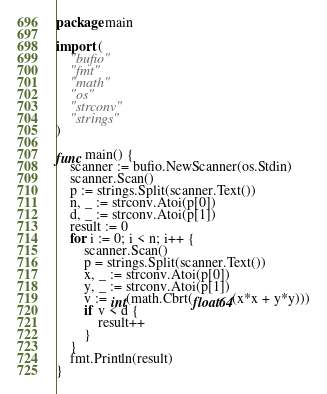Convert code to text. <code><loc_0><loc_0><loc_500><loc_500><_Go_>package main

import (
	"bufio"
	"fmt"
	"math"
	"os"
	"strconv"
  	"strings"
)

func main() {
	scanner := bufio.NewScanner(os.Stdin)
	scanner.Scan()
  	p := strings.Split(scanner.Text())
	n, _ := strconv.Atoi(p[0])
	d, _ := strconv.Atoi(p[1])
	result := 0
	for i := 0; i < n; i++ {
		scanner.Scan()
      	p = strings.Split(scanner.Text())
		x, _ := strconv.Atoi(p[0])
		y, _ := strconv.Atoi(p[1])
      	v := int(math.Cbrt(float64(x*x + y*y)))
		if v < d {
			result++
		}
	}
	fmt.Println(result)
}
</code> 